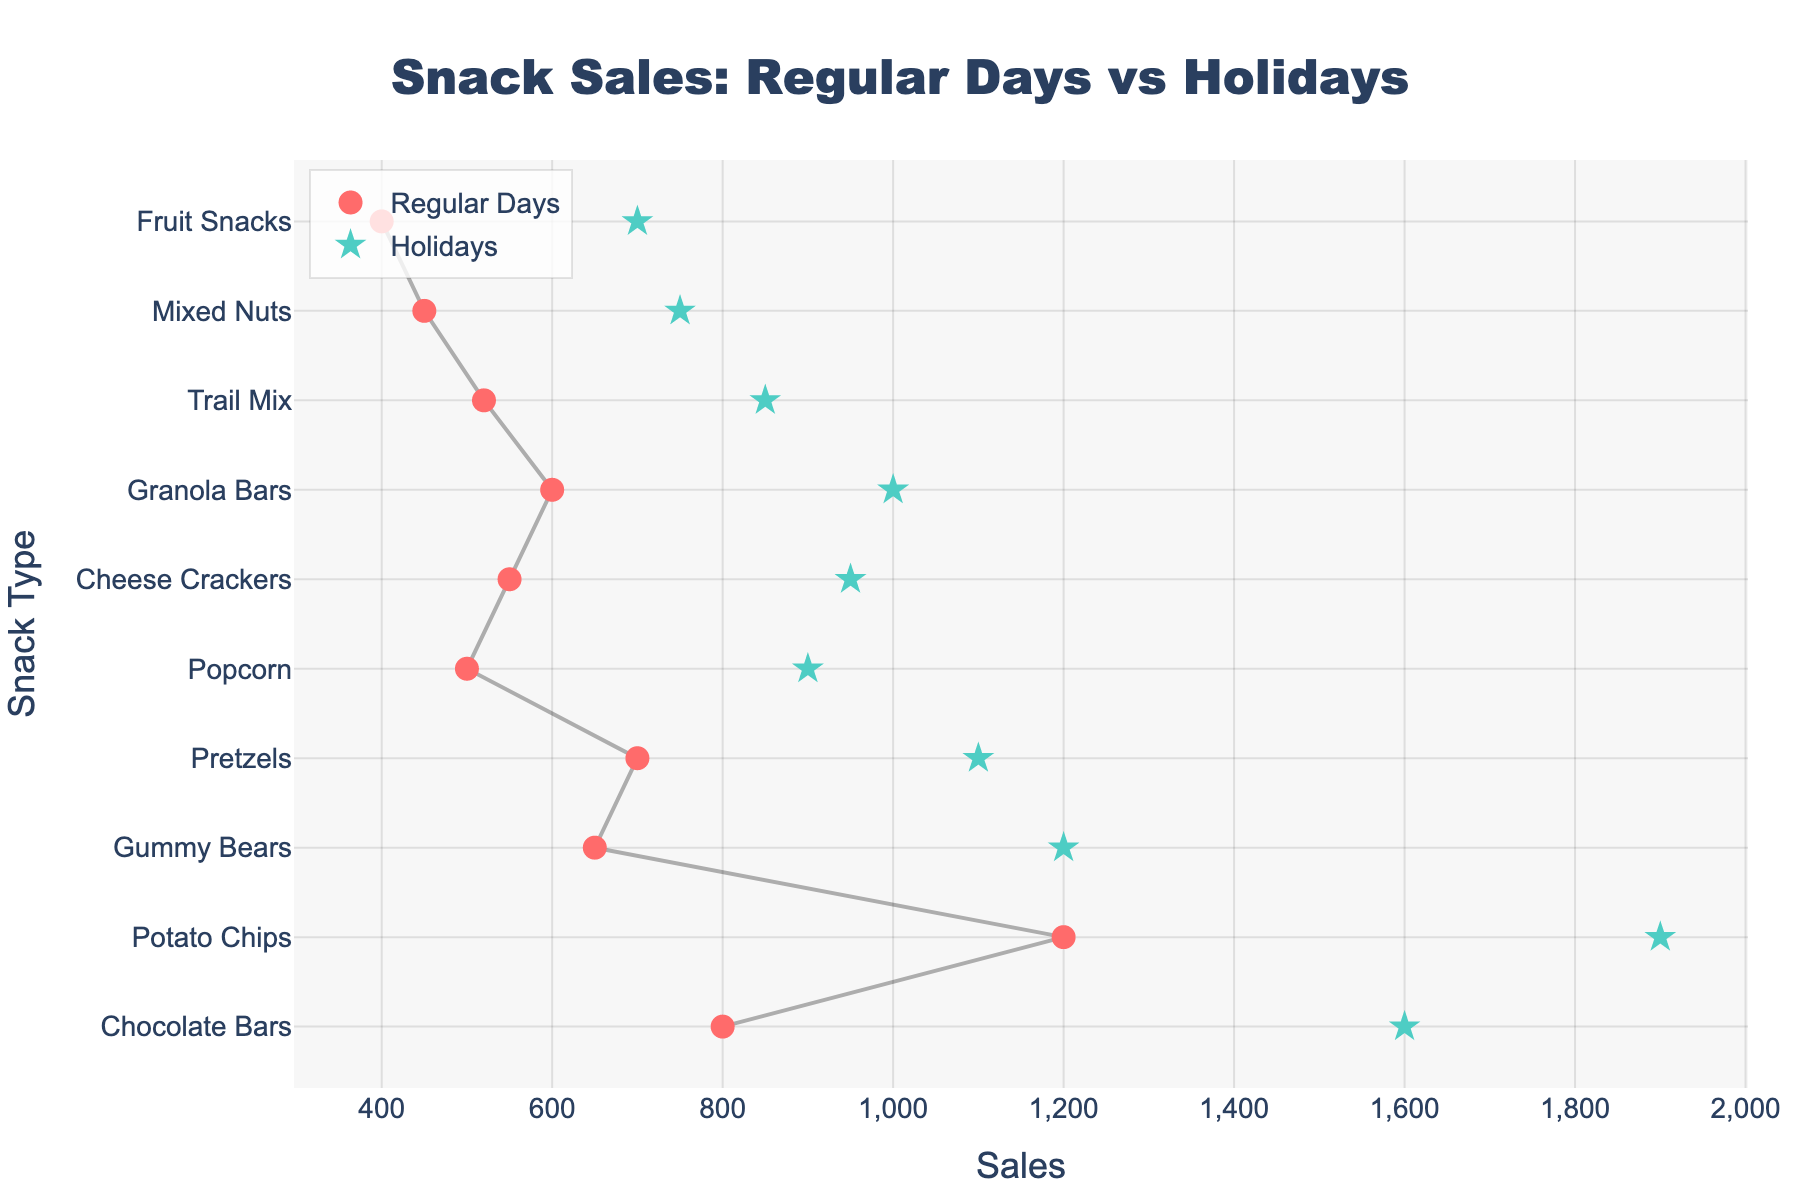How many different snack types are displayed in the figure? The y-axis of the dumbbell plot represents the different snack types. By counting the y-axis labels, we can determine the number of snack types.
Answer: 10 What is the title of the figure? The title of the figure is usually displayed at the top of the plot.
Answer: Snack Sales: Regular Days vs Holidays What color represents the sales on regular days? The markers for regular day sales are colored, and examining the color of these markers will give the answer.
Answer: Red Which snack type has the largest sales increase during holidays compared to regular days? By looking at the length of the lines connecting regular day sales to holiday sales, the longest line indicates the largest sales increase.
Answer: Potato Chips What is the sales difference for Granola Bars between regular days and holidays? Locate Granola Bars on the y-axis and measure the distance between the markers for regular days and holidays on the x-axis.
Answer: 400 Which snack type has the least sales on regular days? Compare the x-axis positions of the regular day markers and identify the one with the smallest value.
Answer: Fruit Snacks What are the sales values for Pretzels on regular days and holidays? Locate Pretzels on the y-axis and read the x-axis values for regular and holiday sales markers.
Answer: 700 (Regular), 1100 (Holidays) How many snack types have holiday sales of 1000 or more? Examine the x-axis values for holiday sales markers and count those that are 1000 or greater.
Answer: 6 Which snack type has the smallest sales increase during holidays compared to regular days? Identify the snack type with the shortest line connecting regular day sales to holiday sales.
Answer: Mixed Nuts Compare the sales difference between Popcorn and Trail Mix on holidays vs. regular days, which has a greater increase? Calculate the difference for Popcorn (900 - 500 = 400) and Trail Mix (850 - 520 = 330) and compare them.
Answer: Popcorn 